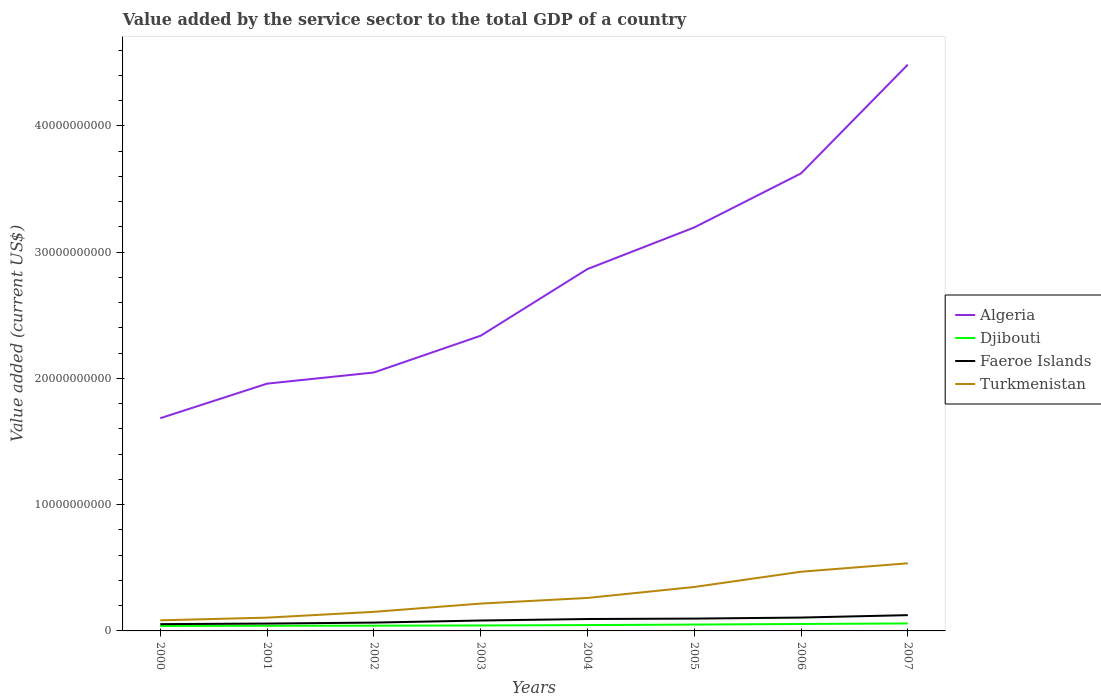Across all years, what is the maximum value added by the service sector to the total GDP in Turkmenistan?
Give a very brief answer. 8.39e+08. In which year was the value added by the service sector to the total GDP in Turkmenistan maximum?
Give a very brief answer. 2000. What is the total value added by the service sector to the total GDP in Djibouti in the graph?
Ensure brevity in your answer.  -9.52e+07. What is the difference between the highest and the second highest value added by the service sector to the total GDP in Djibouti?
Your answer should be very brief. 2.02e+08. What is the difference between the highest and the lowest value added by the service sector to the total GDP in Djibouti?
Provide a short and direct response. 3. How many lines are there?
Offer a terse response. 4. How many years are there in the graph?
Ensure brevity in your answer.  8. What is the difference between two consecutive major ticks on the Y-axis?
Provide a succinct answer. 1.00e+1. Does the graph contain any zero values?
Your answer should be very brief. No. Does the graph contain grids?
Offer a very short reply. No. Where does the legend appear in the graph?
Your response must be concise. Center right. How many legend labels are there?
Offer a terse response. 4. What is the title of the graph?
Ensure brevity in your answer.  Value added by the service sector to the total GDP of a country. Does "Norway" appear as one of the legend labels in the graph?
Provide a succinct answer. No. What is the label or title of the X-axis?
Your response must be concise. Years. What is the label or title of the Y-axis?
Your answer should be compact. Value added (current US$). What is the Value added (current US$) of Algeria in 2000?
Offer a terse response. 1.68e+1. What is the Value added (current US$) in Djibouti in 2000?
Ensure brevity in your answer.  3.90e+08. What is the Value added (current US$) of Faeroe Islands in 2000?
Offer a terse response. 5.37e+08. What is the Value added (current US$) of Turkmenistan in 2000?
Your response must be concise. 8.39e+08. What is the Value added (current US$) in Algeria in 2001?
Your answer should be compact. 1.96e+1. What is the Value added (current US$) in Djibouti in 2001?
Provide a succinct answer. 4.08e+08. What is the Value added (current US$) of Faeroe Islands in 2001?
Offer a terse response. 5.84e+08. What is the Value added (current US$) in Turkmenistan in 2001?
Your answer should be compact. 1.05e+09. What is the Value added (current US$) of Algeria in 2002?
Provide a succinct answer. 2.05e+1. What is the Value added (current US$) in Djibouti in 2002?
Offer a very short reply. 4.16e+08. What is the Value added (current US$) of Faeroe Islands in 2002?
Give a very brief answer. 6.59e+08. What is the Value added (current US$) of Turkmenistan in 2002?
Make the answer very short. 1.51e+09. What is the Value added (current US$) in Algeria in 2003?
Make the answer very short. 2.34e+1. What is the Value added (current US$) in Djibouti in 2003?
Provide a short and direct response. 4.32e+08. What is the Value added (current US$) of Faeroe Islands in 2003?
Offer a very short reply. 8.24e+08. What is the Value added (current US$) of Turkmenistan in 2003?
Make the answer very short. 2.16e+09. What is the Value added (current US$) of Algeria in 2004?
Provide a succinct answer. 2.87e+1. What is the Value added (current US$) of Djibouti in 2004?
Offer a terse response. 4.62e+08. What is the Value added (current US$) of Faeroe Islands in 2004?
Provide a succinct answer. 9.43e+08. What is the Value added (current US$) of Turkmenistan in 2004?
Give a very brief answer. 2.61e+09. What is the Value added (current US$) of Algeria in 2005?
Your answer should be very brief. 3.20e+1. What is the Value added (current US$) of Djibouti in 2005?
Provide a short and direct response. 5.04e+08. What is the Value added (current US$) of Faeroe Islands in 2005?
Keep it short and to the point. 9.77e+08. What is the Value added (current US$) in Turkmenistan in 2005?
Give a very brief answer. 3.48e+09. What is the Value added (current US$) of Algeria in 2006?
Ensure brevity in your answer.  3.62e+1. What is the Value added (current US$) of Djibouti in 2006?
Make the answer very short. 5.49e+08. What is the Value added (current US$) in Faeroe Islands in 2006?
Make the answer very short. 1.06e+09. What is the Value added (current US$) of Turkmenistan in 2006?
Your answer should be very brief. 4.69e+09. What is the Value added (current US$) of Algeria in 2007?
Provide a succinct answer. 4.48e+1. What is the Value added (current US$) of Djibouti in 2007?
Provide a short and direct response. 5.92e+08. What is the Value added (current US$) in Faeroe Islands in 2007?
Offer a very short reply. 1.25e+09. What is the Value added (current US$) of Turkmenistan in 2007?
Make the answer very short. 5.36e+09. Across all years, what is the maximum Value added (current US$) in Algeria?
Your answer should be compact. 4.48e+1. Across all years, what is the maximum Value added (current US$) in Djibouti?
Provide a short and direct response. 5.92e+08. Across all years, what is the maximum Value added (current US$) of Faeroe Islands?
Your response must be concise. 1.25e+09. Across all years, what is the maximum Value added (current US$) of Turkmenistan?
Make the answer very short. 5.36e+09. Across all years, what is the minimum Value added (current US$) in Algeria?
Offer a terse response. 1.68e+1. Across all years, what is the minimum Value added (current US$) of Djibouti?
Your answer should be very brief. 3.90e+08. Across all years, what is the minimum Value added (current US$) of Faeroe Islands?
Provide a short and direct response. 5.37e+08. Across all years, what is the minimum Value added (current US$) in Turkmenistan?
Your response must be concise. 8.39e+08. What is the total Value added (current US$) of Algeria in the graph?
Give a very brief answer. 2.22e+11. What is the total Value added (current US$) of Djibouti in the graph?
Your answer should be very brief. 3.75e+09. What is the total Value added (current US$) in Faeroe Islands in the graph?
Make the answer very short. 6.83e+09. What is the total Value added (current US$) in Turkmenistan in the graph?
Offer a terse response. 2.17e+1. What is the difference between the Value added (current US$) in Algeria in 2000 and that in 2001?
Make the answer very short. -2.74e+09. What is the difference between the Value added (current US$) in Djibouti in 2000 and that in 2001?
Ensure brevity in your answer.  -1.80e+07. What is the difference between the Value added (current US$) of Faeroe Islands in 2000 and that in 2001?
Your answer should be compact. -4.70e+07. What is the difference between the Value added (current US$) in Turkmenistan in 2000 and that in 2001?
Give a very brief answer. -2.13e+08. What is the difference between the Value added (current US$) in Algeria in 2000 and that in 2002?
Your response must be concise. -3.62e+09. What is the difference between the Value added (current US$) in Djibouti in 2000 and that in 2002?
Make the answer very short. -2.58e+07. What is the difference between the Value added (current US$) of Faeroe Islands in 2000 and that in 2002?
Your response must be concise. -1.22e+08. What is the difference between the Value added (current US$) in Turkmenistan in 2000 and that in 2002?
Ensure brevity in your answer.  -6.72e+08. What is the difference between the Value added (current US$) in Algeria in 2000 and that in 2003?
Offer a terse response. -6.53e+09. What is the difference between the Value added (current US$) in Djibouti in 2000 and that in 2003?
Give a very brief answer. -4.19e+07. What is the difference between the Value added (current US$) in Faeroe Islands in 2000 and that in 2003?
Your answer should be very brief. -2.86e+08. What is the difference between the Value added (current US$) of Turkmenistan in 2000 and that in 2003?
Offer a very short reply. -1.33e+09. What is the difference between the Value added (current US$) of Algeria in 2000 and that in 2004?
Give a very brief answer. -1.18e+1. What is the difference between the Value added (current US$) of Djibouti in 2000 and that in 2004?
Make the answer very short. -7.20e+07. What is the difference between the Value added (current US$) of Faeroe Islands in 2000 and that in 2004?
Your answer should be compact. -4.06e+08. What is the difference between the Value added (current US$) in Turkmenistan in 2000 and that in 2004?
Offer a very short reply. -1.77e+09. What is the difference between the Value added (current US$) in Algeria in 2000 and that in 2005?
Provide a succinct answer. -1.51e+1. What is the difference between the Value added (current US$) of Djibouti in 2000 and that in 2005?
Provide a short and direct response. -1.13e+08. What is the difference between the Value added (current US$) of Faeroe Islands in 2000 and that in 2005?
Keep it short and to the point. -4.39e+08. What is the difference between the Value added (current US$) in Turkmenistan in 2000 and that in 2005?
Your answer should be very brief. -2.64e+09. What is the difference between the Value added (current US$) of Algeria in 2000 and that in 2006?
Your response must be concise. -1.94e+1. What is the difference between the Value added (current US$) in Djibouti in 2000 and that in 2006?
Provide a succinct answer. -1.59e+08. What is the difference between the Value added (current US$) in Faeroe Islands in 2000 and that in 2006?
Offer a terse response. -5.21e+08. What is the difference between the Value added (current US$) in Turkmenistan in 2000 and that in 2006?
Provide a short and direct response. -3.85e+09. What is the difference between the Value added (current US$) in Algeria in 2000 and that in 2007?
Provide a short and direct response. -2.80e+1. What is the difference between the Value added (current US$) in Djibouti in 2000 and that in 2007?
Give a very brief answer. -2.02e+08. What is the difference between the Value added (current US$) in Faeroe Islands in 2000 and that in 2007?
Your answer should be very brief. -7.12e+08. What is the difference between the Value added (current US$) of Turkmenistan in 2000 and that in 2007?
Your answer should be compact. -4.52e+09. What is the difference between the Value added (current US$) of Algeria in 2001 and that in 2002?
Your answer should be compact. -8.82e+08. What is the difference between the Value added (current US$) in Djibouti in 2001 and that in 2002?
Your answer should be compact. -7.81e+06. What is the difference between the Value added (current US$) in Faeroe Islands in 2001 and that in 2002?
Provide a succinct answer. -7.46e+07. What is the difference between the Value added (current US$) of Turkmenistan in 2001 and that in 2002?
Offer a terse response. -4.59e+08. What is the difference between the Value added (current US$) of Algeria in 2001 and that in 2003?
Offer a terse response. -3.79e+09. What is the difference between the Value added (current US$) in Djibouti in 2001 and that in 2003?
Offer a very short reply. -2.39e+07. What is the difference between the Value added (current US$) in Faeroe Islands in 2001 and that in 2003?
Provide a succinct answer. -2.39e+08. What is the difference between the Value added (current US$) of Turkmenistan in 2001 and that in 2003?
Your answer should be very brief. -1.11e+09. What is the difference between the Value added (current US$) of Algeria in 2001 and that in 2004?
Your response must be concise. -9.07e+09. What is the difference between the Value added (current US$) of Djibouti in 2001 and that in 2004?
Provide a succinct answer. -5.40e+07. What is the difference between the Value added (current US$) of Faeroe Islands in 2001 and that in 2004?
Give a very brief answer. -3.59e+08. What is the difference between the Value added (current US$) in Turkmenistan in 2001 and that in 2004?
Ensure brevity in your answer.  -1.56e+09. What is the difference between the Value added (current US$) in Algeria in 2001 and that in 2005?
Provide a succinct answer. -1.24e+1. What is the difference between the Value added (current US$) of Djibouti in 2001 and that in 2005?
Keep it short and to the point. -9.52e+07. What is the difference between the Value added (current US$) in Faeroe Islands in 2001 and that in 2005?
Provide a short and direct response. -3.92e+08. What is the difference between the Value added (current US$) in Turkmenistan in 2001 and that in 2005?
Your response must be concise. -2.43e+09. What is the difference between the Value added (current US$) of Algeria in 2001 and that in 2006?
Give a very brief answer. -1.66e+1. What is the difference between the Value added (current US$) in Djibouti in 2001 and that in 2006?
Ensure brevity in your answer.  -1.41e+08. What is the difference between the Value added (current US$) in Faeroe Islands in 2001 and that in 2006?
Provide a short and direct response. -4.74e+08. What is the difference between the Value added (current US$) in Turkmenistan in 2001 and that in 2006?
Your answer should be very brief. -3.64e+09. What is the difference between the Value added (current US$) of Algeria in 2001 and that in 2007?
Provide a short and direct response. -2.53e+1. What is the difference between the Value added (current US$) in Djibouti in 2001 and that in 2007?
Provide a short and direct response. -1.84e+08. What is the difference between the Value added (current US$) of Faeroe Islands in 2001 and that in 2007?
Give a very brief answer. -6.65e+08. What is the difference between the Value added (current US$) in Turkmenistan in 2001 and that in 2007?
Your response must be concise. -4.30e+09. What is the difference between the Value added (current US$) in Algeria in 2002 and that in 2003?
Your response must be concise. -2.91e+09. What is the difference between the Value added (current US$) in Djibouti in 2002 and that in 2003?
Give a very brief answer. -1.61e+07. What is the difference between the Value added (current US$) in Faeroe Islands in 2002 and that in 2003?
Give a very brief answer. -1.65e+08. What is the difference between the Value added (current US$) in Turkmenistan in 2002 and that in 2003?
Provide a succinct answer. -6.54e+08. What is the difference between the Value added (current US$) of Algeria in 2002 and that in 2004?
Offer a very short reply. -8.19e+09. What is the difference between the Value added (current US$) in Djibouti in 2002 and that in 2004?
Offer a terse response. -4.62e+07. What is the difference between the Value added (current US$) of Faeroe Islands in 2002 and that in 2004?
Provide a succinct answer. -2.84e+08. What is the difference between the Value added (current US$) in Turkmenistan in 2002 and that in 2004?
Provide a short and direct response. -1.10e+09. What is the difference between the Value added (current US$) in Algeria in 2002 and that in 2005?
Your answer should be compact. -1.15e+1. What is the difference between the Value added (current US$) of Djibouti in 2002 and that in 2005?
Your response must be concise. -8.74e+07. What is the difference between the Value added (current US$) of Faeroe Islands in 2002 and that in 2005?
Your response must be concise. -3.18e+08. What is the difference between the Value added (current US$) in Turkmenistan in 2002 and that in 2005?
Provide a short and direct response. -1.97e+09. What is the difference between the Value added (current US$) in Algeria in 2002 and that in 2006?
Your response must be concise. -1.58e+1. What is the difference between the Value added (current US$) of Djibouti in 2002 and that in 2006?
Offer a terse response. -1.33e+08. What is the difference between the Value added (current US$) of Faeroe Islands in 2002 and that in 2006?
Make the answer very short. -3.99e+08. What is the difference between the Value added (current US$) of Turkmenistan in 2002 and that in 2006?
Your answer should be compact. -3.18e+09. What is the difference between the Value added (current US$) of Algeria in 2002 and that in 2007?
Ensure brevity in your answer.  -2.44e+1. What is the difference between the Value added (current US$) of Djibouti in 2002 and that in 2007?
Give a very brief answer. -1.76e+08. What is the difference between the Value added (current US$) in Faeroe Islands in 2002 and that in 2007?
Make the answer very short. -5.91e+08. What is the difference between the Value added (current US$) in Turkmenistan in 2002 and that in 2007?
Make the answer very short. -3.84e+09. What is the difference between the Value added (current US$) of Algeria in 2003 and that in 2004?
Make the answer very short. -5.28e+09. What is the difference between the Value added (current US$) in Djibouti in 2003 and that in 2004?
Offer a terse response. -3.01e+07. What is the difference between the Value added (current US$) of Faeroe Islands in 2003 and that in 2004?
Provide a short and direct response. -1.20e+08. What is the difference between the Value added (current US$) of Turkmenistan in 2003 and that in 2004?
Provide a short and direct response. -4.47e+08. What is the difference between the Value added (current US$) of Algeria in 2003 and that in 2005?
Give a very brief answer. -8.58e+09. What is the difference between the Value added (current US$) of Djibouti in 2003 and that in 2005?
Your answer should be compact. -7.13e+07. What is the difference between the Value added (current US$) of Faeroe Islands in 2003 and that in 2005?
Your answer should be compact. -1.53e+08. What is the difference between the Value added (current US$) of Turkmenistan in 2003 and that in 2005?
Your response must be concise. -1.32e+09. What is the difference between the Value added (current US$) in Algeria in 2003 and that in 2006?
Give a very brief answer. -1.29e+1. What is the difference between the Value added (current US$) in Djibouti in 2003 and that in 2006?
Your response must be concise. -1.17e+08. What is the difference between the Value added (current US$) of Faeroe Islands in 2003 and that in 2006?
Provide a short and direct response. -2.35e+08. What is the difference between the Value added (current US$) of Turkmenistan in 2003 and that in 2006?
Ensure brevity in your answer.  -2.52e+09. What is the difference between the Value added (current US$) of Algeria in 2003 and that in 2007?
Provide a succinct answer. -2.15e+1. What is the difference between the Value added (current US$) in Djibouti in 2003 and that in 2007?
Provide a short and direct response. -1.60e+08. What is the difference between the Value added (current US$) of Faeroe Islands in 2003 and that in 2007?
Offer a terse response. -4.26e+08. What is the difference between the Value added (current US$) of Turkmenistan in 2003 and that in 2007?
Provide a succinct answer. -3.19e+09. What is the difference between the Value added (current US$) in Algeria in 2004 and that in 2005?
Provide a short and direct response. -3.29e+09. What is the difference between the Value added (current US$) of Djibouti in 2004 and that in 2005?
Your response must be concise. -4.12e+07. What is the difference between the Value added (current US$) of Faeroe Islands in 2004 and that in 2005?
Provide a succinct answer. -3.36e+07. What is the difference between the Value added (current US$) of Turkmenistan in 2004 and that in 2005?
Your answer should be compact. -8.68e+08. What is the difference between the Value added (current US$) of Algeria in 2004 and that in 2006?
Ensure brevity in your answer.  -7.58e+09. What is the difference between the Value added (current US$) of Djibouti in 2004 and that in 2006?
Your response must be concise. -8.69e+07. What is the difference between the Value added (current US$) of Faeroe Islands in 2004 and that in 2006?
Give a very brief answer. -1.15e+08. What is the difference between the Value added (current US$) in Turkmenistan in 2004 and that in 2006?
Provide a succinct answer. -2.08e+09. What is the difference between the Value added (current US$) of Algeria in 2004 and that in 2007?
Make the answer very short. -1.62e+1. What is the difference between the Value added (current US$) of Djibouti in 2004 and that in 2007?
Your answer should be very brief. -1.30e+08. What is the difference between the Value added (current US$) of Faeroe Islands in 2004 and that in 2007?
Keep it short and to the point. -3.07e+08. What is the difference between the Value added (current US$) in Turkmenistan in 2004 and that in 2007?
Your answer should be very brief. -2.74e+09. What is the difference between the Value added (current US$) in Algeria in 2005 and that in 2006?
Provide a succinct answer. -4.28e+09. What is the difference between the Value added (current US$) in Djibouti in 2005 and that in 2006?
Offer a terse response. -4.57e+07. What is the difference between the Value added (current US$) in Faeroe Islands in 2005 and that in 2006?
Your answer should be compact. -8.14e+07. What is the difference between the Value added (current US$) of Turkmenistan in 2005 and that in 2006?
Provide a short and direct response. -1.21e+09. What is the difference between the Value added (current US$) of Algeria in 2005 and that in 2007?
Give a very brief answer. -1.29e+1. What is the difference between the Value added (current US$) of Djibouti in 2005 and that in 2007?
Your answer should be compact. -8.87e+07. What is the difference between the Value added (current US$) in Faeroe Islands in 2005 and that in 2007?
Keep it short and to the point. -2.73e+08. What is the difference between the Value added (current US$) in Turkmenistan in 2005 and that in 2007?
Ensure brevity in your answer.  -1.88e+09. What is the difference between the Value added (current US$) in Algeria in 2006 and that in 2007?
Provide a succinct answer. -8.61e+09. What is the difference between the Value added (current US$) of Djibouti in 2006 and that in 2007?
Your response must be concise. -4.30e+07. What is the difference between the Value added (current US$) in Faeroe Islands in 2006 and that in 2007?
Keep it short and to the point. -1.92e+08. What is the difference between the Value added (current US$) in Turkmenistan in 2006 and that in 2007?
Provide a short and direct response. -6.68e+08. What is the difference between the Value added (current US$) of Algeria in 2000 and the Value added (current US$) of Djibouti in 2001?
Make the answer very short. 1.64e+1. What is the difference between the Value added (current US$) in Algeria in 2000 and the Value added (current US$) in Faeroe Islands in 2001?
Provide a succinct answer. 1.63e+1. What is the difference between the Value added (current US$) in Algeria in 2000 and the Value added (current US$) in Turkmenistan in 2001?
Give a very brief answer. 1.58e+1. What is the difference between the Value added (current US$) in Djibouti in 2000 and the Value added (current US$) in Faeroe Islands in 2001?
Offer a terse response. -1.94e+08. What is the difference between the Value added (current US$) of Djibouti in 2000 and the Value added (current US$) of Turkmenistan in 2001?
Make the answer very short. -6.62e+08. What is the difference between the Value added (current US$) of Faeroe Islands in 2000 and the Value added (current US$) of Turkmenistan in 2001?
Give a very brief answer. -5.15e+08. What is the difference between the Value added (current US$) in Algeria in 2000 and the Value added (current US$) in Djibouti in 2002?
Your response must be concise. 1.64e+1. What is the difference between the Value added (current US$) of Algeria in 2000 and the Value added (current US$) of Faeroe Islands in 2002?
Offer a terse response. 1.62e+1. What is the difference between the Value added (current US$) in Algeria in 2000 and the Value added (current US$) in Turkmenistan in 2002?
Your answer should be compact. 1.53e+1. What is the difference between the Value added (current US$) of Djibouti in 2000 and the Value added (current US$) of Faeroe Islands in 2002?
Keep it short and to the point. -2.69e+08. What is the difference between the Value added (current US$) of Djibouti in 2000 and the Value added (current US$) of Turkmenistan in 2002?
Offer a very short reply. -1.12e+09. What is the difference between the Value added (current US$) of Faeroe Islands in 2000 and the Value added (current US$) of Turkmenistan in 2002?
Give a very brief answer. -9.74e+08. What is the difference between the Value added (current US$) of Algeria in 2000 and the Value added (current US$) of Djibouti in 2003?
Offer a terse response. 1.64e+1. What is the difference between the Value added (current US$) in Algeria in 2000 and the Value added (current US$) in Faeroe Islands in 2003?
Offer a terse response. 1.60e+1. What is the difference between the Value added (current US$) in Algeria in 2000 and the Value added (current US$) in Turkmenistan in 2003?
Ensure brevity in your answer.  1.47e+1. What is the difference between the Value added (current US$) of Djibouti in 2000 and the Value added (current US$) of Faeroe Islands in 2003?
Your answer should be very brief. -4.33e+08. What is the difference between the Value added (current US$) of Djibouti in 2000 and the Value added (current US$) of Turkmenistan in 2003?
Give a very brief answer. -1.77e+09. What is the difference between the Value added (current US$) in Faeroe Islands in 2000 and the Value added (current US$) in Turkmenistan in 2003?
Offer a very short reply. -1.63e+09. What is the difference between the Value added (current US$) in Algeria in 2000 and the Value added (current US$) in Djibouti in 2004?
Provide a succinct answer. 1.64e+1. What is the difference between the Value added (current US$) of Algeria in 2000 and the Value added (current US$) of Faeroe Islands in 2004?
Your answer should be compact. 1.59e+1. What is the difference between the Value added (current US$) in Algeria in 2000 and the Value added (current US$) in Turkmenistan in 2004?
Offer a terse response. 1.42e+1. What is the difference between the Value added (current US$) in Djibouti in 2000 and the Value added (current US$) in Faeroe Islands in 2004?
Your answer should be compact. -5.53e+08. What is the difference between the Value added (current US$) in Djibouti in 2000 and the Value added (current US$) in Turkmenistan in 2004?
Your answer should be compact. -2.22e+09. What is the difference between the Value added (current US$) in Faeroe Islands in 2000 and the Value added (current US$) in Turkmenistan in 2004?
Ensure brevity in your answer.  -2.07e+09. What is the difference between the Value added (current US$) of Algeria in 2000 and the Value added (current US$) of Djibouti in 2005?
Keep it short and to the point. 1.63e+1. What is the difference between the Value added (current US$) of Algeria in 2000 and the Value added (current US$) of Faeroe Islands in 2005?
Make the answer very short. 1.59e+1. What is the difference between the Value added (current US$) of Algeria in 2000 and the Value added (current US$) of Turkmenistan in 2005?
Keep it short and to the point. 1.34e+1. What is the difference between the Value added (current US$) of Djibouti in 2000 and the Value added (current US$) of Faeroe Islands in 2005?
Make the answer very short. -5.86e+08. What is the difference between the Value added (current US$) of Djibouti in 2000 and the Value added (current US$) of Turkmenistan in 2005?
Give a very brief answer. -3.09e+09. What is the difference between the Value added (current US$) in Faeroe Islands in 2000 and the Value added (current US$) in Turkmenistan in 2005?
Provide a short and direct response. -2.94e+09. What is the difference between the Value added (current US$) in Algeria in 2000 and the Value added (current US$) in Djibouti in 2006?
Keep it short and to the point. 1.63e+1. What is the difference between the Value added (current US$) of Algeria in 2000 and the Value added (current US$) of Faeroe Islands in 2006?
Make the answer very short. 1.58e+1. What is the difference between the Value added (current US$) in Algeria in 2000 and the Value added (current US$) in Turkmenistan in 2006?
Provide a short and direct response. 1.22e+1. What is the difference between the Value added (current US$) of Djibouti in 2000 and the Value added (current US$) of Faeroe Islands in 2006?
Make the answer very short. -6.68e+08. What is the difference between the Value added (current US$) of Djibouti in 2000 and the Value added (current US$) of Turkmenistan in 2006?
Provide a succinct answer. -4.30e+09. What is the difference between the Value added (current US$) in Faeroe Islands in 2000 and the Value added (current US$) in Turkmenistan in 2006?
Keep it short and to the point. -4.15e+09. What is the difference between the Value added (current US$) of Algeria in 2000 and the Value added (current US$) of Djibouti in 2007?
Give a very brief answer. 1.63e+1. What is the difference between the Value added (current US$) of Algeria in 2000 and the Value added (current US$) of Faeroe Islands in 2007?
Provide a short and direct response. 1.56e+1. What is the difference between the Value added (current US$) of Algeria in 2000 and the Value added (current US$) of Turkmenistan in 2007?
Your answer should be very brief. 1.15e+1. What is the difference between the Value added (current US$) of Djibouti in 2000 and the Value added (current US$) of Faeroe Islands in 2007?
Provide a succinct answer. -8.59e+08. What is the difference between the Value added (current US$) in Djibouti in 2000 and the Value added (current US$) in Turkmenistan in 2007?
Your response must be concise. -4.97e+09. What is the difference between the Value added (current US$) in Faeroe Islands in 2000 and the Value added (current US$) in Turkmenistan in 2007?
Your response must be concise. -4.82e+09. What is the difference between the Value added (current US$) of Algeria in 2001 and the Value added (current US$) of Djibouti in 2002?
Make the answer very short. 1.92e+1. What is the difference between the Value added (current US$) in Algeria in 2001 and the Value added (current US$) in Faeroe Islands in 2002?
Your answer should be compact. 1.89e+1. What is the difference between the Value added (current US$) in Algeria in 2001 and the Value added (current US$) in Turkmenistan in 2002?
Your answer should be very brief. 1.81e+1. What is the difference between the Value added (current US$) of Djibouti in 2001 and the Value added (current US$) of Faeroe Islands in 2002?
Give a very brief answer. -2.51e+08. What is the difference between the Value added (current US$) in Djibouti in 2001 and the Value added (current US$) in Turkmenistan in 2002?
Your answer should be compact. -1.10e+09. What is the difference between the Value added (current US$) of Faeroe Islands in 2001 and the Value added (current US$) of Turkmenistan in 2002?
Offer a very short reply. -9.27e+08. What is the difference between the Value added (current US$) in Algeria in 2001 and the Value added (current US$) in Djibouti in 2003?
Make the answer very short. 1.91e+1. What is the difference between the Value added (current US$) in Algeria in 2001 and the Value added (current US$) in Faeroe Islands in 2003?
Offer a very short reply. 1.88e+1. What is the difference between the Value added (current US$) of Algeria in 2001 and the Value added (current US$) of Turkmenistan in 2003?
Your response must be concise. 1.74e+1. What is the difference between the Value added (current US$) in Djibouti in 2001 and the Value added (current US$) in Faeroe Islands in 2003?
Ensure brevity in your answer.  -4.15e+08. What is the difference between the Value added (current US$) in Djibouti in 2001 and the Value added (current US$) in Turkmenistan in 2003?
Provide a succinct answer. -1.76e+09. What is the difference between the Value added (current US$) in Faeroe Islands in 2001 and the Value added (current US$) in Turkmenistan in 2003?
Provide a short and direct response. -1.58e+09. What is the difference between the Value added (current US$) of Algeria in 2001 and the Value added (current US$) of Djibouti in 2004?
Offer a terse response. 1.91e+1. What is the difference between the Value added (current US$) in Algeria in 2001 and the Value added (current US$) in Faeroe Islands in 2004?
Ensure brevity in your answer.  1.86e+1. What is the difference between the Value added (current US$) in Algeria in 2001 and the Value added (current US$) in Turkmenistan in 2004?
Your response must be concise. 1.70e+1. What is the difference between the Value added (current US$) of Djibouti in 2001 and the Value added (current US$) of Faeroe Islands in 2004?
Provide a succinct answer. -5.35e+08. What is the difference between the Value added (current US$) of Djibouti in 2001 and the Value added (current US$) of Turkmenistan in 2004?
Give a very brief answer. -2.20e+09. What is the difference between the Value added (current US$) of Faeroe Islands in 2001 and the Value added (current US$) of Turkmenistan in 2004?
Provide a short and direct response. -2.03e+09. What is the difference between the Value added (current US$) of Algeria in 2001 and the Value added (current US$) of Djibouti in 2005?
Make the answer very short. 1.91e+1. What is the difference between the Value added (current US$) in Algeria in 2001 and the Value added (current US$) in Faeroe Islands in 2005?
Make the answer very short. 1.86e+1. What is the difference between the Value added (current US$) of Algeria in 2001 and the Value added (current US$) of Turkmenistan in 2005?
Provide a short and direct response. 1.61e+1. What is the difference between the Value added (current US$) in Djibouti in 2001 and the Value added (current US$) in Faeroe Islands in 2005?
Give a very brief answer. -5.68e+08. What is the difference between the Value added (current US$) of Djibouti in 2001 and the Value added (current US$) of Turkmenistan in 2005?
Provide a short and direct response. -3.07e+09. What is the difference between the Value added (current US$) of Faeroe Islands in 2001 and the Value added (current US$) of Turkmenistan in 2005?
Your response must be concise. -2.90e+09. What is the difference between the Value added (current US$) of Algeria in 2001 and the Value added (current US$) of Djibouti in 2006?
Offer a very short reply. 1.90e+1. What is the difference between the Value added (current US$) in Algeria in 2001 and the Value added (current US$) in Faeroe Islands in 2006?
Offer a very short reply. 1.85e+1. What is the difference between the Value added (current US$) of Algeria in 2001 and the Value added (current US$) of Turkmenistan in 2006?
Your response must be concise. 1.49e+1. What is the difference between the Value added (current US$) of Djibouti in 2001 and the Value added (current US$) of Faeroe Islands in 2006?
Keep it short and to the point. -6.50e+08. What is the difference between the Value added (current US$) of Djibouti in 2001 and the Value added (current US$) of Turkmenistan in 2006?
Provide a short and direct response. -4.28e+09. What is the difference between the Value added (current US$) in Faeroe Islands in 2001 and the Value added (current US$) in Turkmenistan in 2006?
Ensure brevity in your answer.  -4.10e+09. What is the difference between the Value added (current US$) of Algeria in 2001 and the Value added (current US$) of Djibouti in 2007?
Offer a terse response. 1.90e+1. What is the difference between the Value added (current US$) of Algeria in 2001 and the Value added (current US$) of Faeroe Islands in 2007?
Your answer should be very brief. 1.83e+1. What is the difference between the Value added (current US$) of Algeria in 2001 and the Value added (current US$) of Turkmenistan in 2007?
Ensure brevity in your answer.  1.42e+1. What is the difference between the Value added (current US$) of Djibouti in 2001 and the Value added (current US$) of Faeroe Islands in 2007?
Make the answer very short. -8.41e+08. What is the difference between the Value added (current US$) in Djibouti in 2001 and the Value added (current US$) in Turkmenistan in 2007?
Make the answer very short. -4.95e+09. What is the difference between the Value added (current US$) in Faeroe Islands in 2001 and the Value added (current US$) in Turkmenistan in 2007?
Provide a short and direct response. -4.77e+09. What is the difference between the Value added (current US$) in Algeria in 2002 and the Value added (current US$) in Djibouti in 2003?
Ensure brevity in your answer.  2.00e+1. What is the difference between the Value added (current US$) of Algeria in 2002 and the Value added (current US$) of Faeroe Islands in 2003?
Your answer should be compact. 1.96e+1. What is the difference between the Value added (current US$) of Algeria in 2002 and the Value added (current US$) of Turkmenistan in 2003?
Provide a succinct answer. 1.83e+1. What is the difference between the Value added (current US$) of Djibouti in 2002 and the Value added (current US$) of Faeroe Islands in 2003?
Give a very brief answer. -4.07e+08. What is the difference between the Value added (current US$) in Djibouti in 2002 and the Value added (current US$) in Turkmenistan in 2003?
Ensure brevity in your answer.  -1.75e+09. What is the difference between the Value added (current US$) of Faeroe Islands in 2002 and the Value added (current US$) of Turkmenistan in 2003?
Ensure brevity in your answer.  -1.51e+09. What is the difference between the Value added (current US$) in Algeria in 2002 and the Value added (current US$) in Djibouti in 2004?
Offer a terse response. 2.00e+1. What is the difference between the Value added (current US$) in Algeria in 2002 and the Value added (current US$) in Faeroe Islands in 2004?
Give a very brief answer. 1.95e+1. What is the difference between the Value added (current US$) in Algeria in 2002 and the Value added (current US$) in Turkmenistan in 2004?
Make the answer very short. 1.79e+1. What is the difference between the Value added (current US$) in Djibouti in 2002 and the Value added (current US$) in Faeroe Islands in 2004?
Provide a short and direct response. -5.27e+08. What is the difference between the Value added (current US$) of Djibouti in 2002 and the Value added (current US$) of Turkmenistan in 2004?
Provide a succinct answer. -2.20e+09. What is the difference between the Value added (current US$) of Faeroe Islands in 2002 and the Value added (current US$) of Turkmenistan in 2004?
Your response must be concise. -1.95e+09. What is the difference between the Value added (current US$) in Algeria in 2002 and the Value added (current US$) in Djibouti in 2005?
Ensure brevity in your answer.  2.00e+1. What is the difference between the Value added (current US$) in Algeria in 2002 and the Value added (current US$) in Faeroe Islands in 2005?
Your answer should be very brief. 1.95e+1. What is the difference between the Value added (current US$) in Algeria in 2002 and the Value added (current US$) in Turkmenistan in 2005?
Your answer should be compact. 1.70e+1. What is the difference between the Value added (current US$) in Djibouti in 2002 and the Value added (current US$) in Faeroe Islands in 2005?
Make the answer very short. -5.60e+08. What is the difference between the Value added (current US$) in Djibouti in 2002 and the Value added (current US$) in Turkmenistan in 2005?
Your response must be concise. -3.06e+09. What is the difference between the Value added (current US$) in Faeroe Islands in 2002 and the Value added (current US$) in Turkmenistan in 2005?
Your answer should be very brief. -2.82e+09. What is the difference between the Value added (current US$) in Algeria in 2002 and the Value added (current US$) in Djibouti in 2006?
Keep it short and to the point. 1.99e+1. What is the difference between the Value added (current US$) of Algeria in 2002 and the Value added (current US$) of Faeroe Islands in 2006?
Make the answer very short. 1.94e+1. What is the difference between the Value added (current US$) of Algeria in 2002 and the Value added (current US$) of Turkmenistan in 2006?
Keep it short and to the point. 1.58e+1. What is the difference between the Value added (current US$) in Djibouti in 2002 and the Value added (current US$) in Faeroe Islands in 2006?
Make the answer very short. -6.42e+08. What is the difference between the Value added (current US$) in Djibouti in 2002 and the Value added (current US$) in Turkmenistan in 2006?
Ensure brevity in your answer.  -4.27e+09. What is the difference between the Value added (current US$) in Faeroe Islands in 2002 and the Value added (current US$) in Turkmenistan in 2006?
Your response must be concise. -4.03e+09. What is the difference between the Value added (current US$) of Algeria in 2002 and the Value added (current US$) of Djibouti in 2007?
Ensure brevity in your answer.  1.99e+1. What is the difference between the Value added (current US$) in Algeria in 2002 and the Value added (current US$) in Faeroe Islands in 2007?
Provide a succinct answer. 1.92e+1. What is the difference between the Value added (current US$) in Algeria in 2002 and the Value added (current US$) in Turkmenistan in 2007?
Offer a very short reply. 1.51e+1. What is the difference between the Value added (current US$) of Djibouti in 2002 and the Value added (current US$) of Faeroe Islands in 2007?
Your answer should be compact. -8.34e+08. What is the difference between the Value added (current US$) in Djibouti in 2002 and the Value added (current US$) in Turkmenistan in 2007?
Ensure brevity in your answer.  -4.94e+09. What is the difference between the Value added (current US$) in Faeroe Islands in 2002 and the Value added (current US$) in Turkmenistan in 2007?
Your response must be concise. -4.70e+09. What is the difference between the Value added (current US$) of Algeria in 2003 and the Value added (current US$) of Djibouti in 2004?
Your answer should be very brief. 2.29e+1. What is the difference between the Value added (current US$) in Algeria in 2003 and the Value added (current US$) in Faeroe Islands in 2004?
Offer a terse response. 2.24e+1. What is the difference between the Value added (current US$) in Algeria in 2003 and the Value added (current US$) in Turkmenistan in 2004?
Your answer should be compact. 2.08e+1. What is the difference between the Value added (current US$) in Djibouti in 2003 and the Value added (current US$) in Faeroe Islands in 2004?
Your answer should be compact. -5.11e+08. What is the difference between the Value added (current US$) in Djibouti in 2003 and the Value added (current US$) in Turkmenistan in 2004?
Give a very brief answer. -2.18e+09. What is the difference between the Value added (current US$) in Faeroe Islands in 2003 and the Value added (current US$) in Turkmenistan in 2004?
Your answer should be very brief. -1.79e+09. What is the difference between the Value added (current US$) in Algeria in 2003 and the Value added (current US$) in Djibouti in 2005?
Offer a very short reply. 2.29e+1. What is the difference between the Value added (current US$) of Algeria in 2003 and the Value added (current US$) of Faeroe Islands in 2005?
Provide a succinct answer. 2.24e+1. What is the difference between the Value added (current US$) of Algeria in 2003 and the Value added (current US$) of Turkmenistan in 2005?
Provide a short and direct response. 1.99e+1. What is the difference between the Value added (current US$) of Djibouti in 2003 and the Value added (current US$) of Faeroe Islands in 2005?
Make the answer very short. -5.44e+08. What is the difference between the Value added (current US$) of Djibouti in 2003 and the Value added (current US$) of Turkmenistan in 2005?
Your response must be concise. -3.05e+09. What is the difference between the Value added (current US$) of Faeroe Islands in 2003 and the Value added (current US$) of Turkmenistan in 2005?
Provide a succinct answer. -2.66e+09. What is the difference between the Value added (current US$) of Algeria in 2003 and the Value added (current US$) of Djibouti in 2006?
Your answer should be very brief. 2.28e+1. What is the difference between the Value added (current US$) of Algeria in 2003 and the Value added (current US$) of Faeroe Islands in 2006?
Your response must be concise. 2.23e+1. What is the difference between the Value added (current US$) of Algeria in 2003 and the Value added (current US$) of Turkmenistan in 2006?
Keep it short and to the point. 1.87e+1. What is the difference between the Value added (current US$) in Djibouti in 2003 and the Value added (current US$) in Faeroe Islands in 2006?
Keep it short and to the point. -6.26e+08. What is the difference between the Value added (current US$) in Djibouti in 2003 and the Value added (current US$) in Turkmenistan in 2006?
Make the answer very short. -4.26e+09. What is the difference between the Value added (current US$) in Faeroe Islands in 2003 and the Value added (current US$) in Turkmenistan in 2006?
Provide a short and direct response. -3.86e+09. What is the difference between the Value added (current US$) of Algeria in 2003 and the Value added (current US$) of Djibouti in 2007?
Provide a succinct answer. 2.28e+1. What is the difference between the Value added (current US$) in Algeria in 2003 and the Value added (current US$) in Faeroe Islands in 2007?
Give a very brief answer. 2.21e+1. What is the difference between the Value added (current US$) in Algeria in 2003 and the Value added (current US$) in Turkmenistan in 2007?
Ensure brevity in your answer.  1.80e+1. What is the difference between the Value added (current US$) of Djibouti in 2003 and the Value added (current US$) of Faeroe Islands in 2007?
Offer a very short reply. -8.17e+08. What is the difference between the Value added (current US$) of Djibouti in 2003 and the Value added (current US$) of Turkmenistan in 2007?
Provide a short and direct response. -4.92e+09. What is the difference between the Value added (current US$) of Faeroe Islands in 2003 and the Value added (current US$) of Turkmenistan in 2007?
Offer a very short reply. -4.53e+09. What is the difference between the Value added (current US$) in Algeria in 2004 and the Value added (current US$) in Djibouti in 2005?
Your answer should be very brief. 2.82e+1. What is the difference between the Value added (current US$) of Algeria in 2004 and the Value added (current US$) of Faeroe Islands in 2005?
Offer a very short reply. 2.77e+1. What is the difference between the Value added (current US$) of Algeria in 2004 and the Value added (current US$) of Turkmenistan in 2005?
Your response must be concise. 2.52e+1. What is the difference between the Value added (current US$) in Djibouti in 2004 and the Value added (current US$) in Faeroe Islands in 2005?
Offer a terse response. -5.14e+08. What is the difference between the Value added (current US$) in Djibouti in 2004 and the Value added (current US$) in Turkmenistan in 2005?
Make the answer very short. -3.02e+09. What is the difference between the Value added (current US$) of Faeroe Islands in 2004 and the Value added (current US$) of Turkmenistan in 2005?
Your answer should be compact. -2.54e+09. What is the difference between the Value added (current US$) of Algeria in 2004 and the Value added (current US$) of Djibouti in 2006?
Provide a short and direct response. 2.81e+1. What is the difference between the Value added (current US$) in Algeria in 2004 and the Value added (current US$) in Faeroe Islands in 2006?
Your response must be concise. 2.76e+1. What is the difference between the Value added (current US$) in Algeria in 2004 and the Value added (current US$) in Turkmenistan in 2006?
Give a very brief answer. 2.40e+1. What is the difference between the Value added (current US$) in Djibouti in 2004 and the Value added (current US$) in Faeroe Islands in 2006?
Keep it short and to the point. -5.96e+08. What is the difference between the Value added (current US$) in Djibouti in 2004 and the Value added (current US$) in Turkmenistan in 2006?
Your response must be concise. -4.22e+09. What is the difference between the Value added (current US$) in Faeroe Islands in 2004 and the Value added (current US$) in Turkmenistan in 2006?
Your response must be concise. -3.74e+09. What is the difference between the Value added (current US$) of Algeria in 2004 and the Value added (current US$) of Djibouti in 2007?
Keep it short and to the point. 2.81e+1. What is the difference between the Value added (current US$) in Algeria in 2004 and the Value added (current US$) in Faeroe Islands in 2007?
Keep it short and to the point. 2.74e+1. What is the difference between the Value added (current US$) in Algeria in 2004 and the Value added (current US$) in Turkmenistan in 2007?
Keep it short and to the point. 2.33e+1. What is the difference between the Value added (current US$) in Djibouti in 2004 and the Value added (current US$) in Faeroe Islands in 2007?
Your answer should be very brief. -7.87e+08. What is the difference between the Value added (current US$) in Djibouti in 2004 and the Value added (current US$) in Turkmenistan in 2007?
Provide a succinct answer. -4.89e+09. What is the difference between the Value added (current US$) of Faeroe Islands in 2004 and the Value added (current US$) of Turkmenistan in 2007?
Offer a terse response. -4.41e+09. What is the difference between the Value added (current US$) in Algeria in 2005 and the Value added (current US$) in Djibouti in 2006?
Make the answer very short. 3.14e+1. What is the difference between the Value added (current US$) in Algeria in 2005 and the Value added (current US$) in Faeroe Islands in 2006?
Provide a short and direct response. 3.09e+1. What is the difference between the Value added (current US$) of Algeria in 2005 and the Value added (current US$) of Turkmenistan in 2006?
Ensure brevity in your answer.  2.73e+1. What is the difference between the Value added (current US$) in Djibouti in 2005 and the Value added (current US$) in Faeroe Islands in 2006?
Provide a succinct answer. -5.54e+08. What is the difference between the Value added (current US$) of Djibouti in 2005 and the Value added (current US$) of Turkmenistan in 2006?
Your response must be concise. -4.18e+09. What is the difference between the Value added (current US$) of Faeroe Islands in 2005 and the Value added (current US$) of Turkmenistan in 2006?
Provide a short and direct response. -3.71e+09. What is the difference between the Value added (current US$) of Algeria in 2005 and the Value added (current US$) of Djibouti in 2007?
Make the answer very short. 3.14e+1. What is the difference between the Value added (current US$) in Algeria in 2005 and the Value added (current US$) in Faeroe Islands in 2007?
Make the answer very short. 3.07e+1. What is the difference between the Value added (current US$) of Algeria in 2005 and the Value added (current US$) of Turkmenistan in 2007?
Your answer should be very brief. 2.66e+1. What is the difference between the Value added (current US$) of Djibouti in 2005 and the Value added (current US$) of Faeroe Islands in 2007?
Provide a succinct answer. -7.46e+08. What is the difference between the Value added (current US$) of Djibouti in 2005 and the Value added (current US$) of Turkmenistan in 2007?
Provide a succinct answer. -4.85e+09. What is the difference between the Value added (current US$) in Faeroe Islands in 2005 and the Value added (current US$) in Turkmenistan in 2007?
Your answer should be compact. -4.38e+09. What is the difference between the Value added (current US$) of Algeria in 2006 and the Value added (current US$) of Djibouti in 2007?
Provide a short and direct response. 3.56e+1. What is the difference between the Value added (current US$) of Algeria in 2006 and the Value added (current US$) of Faeroe Islands in 2007?
Keep it short and to the point. 3.50e+1. What is the difference between the Value added (current US$) of Algeria in 2006 and the Value added (current US$) of Turkmenistan in 2007?
Provide a succinct answer. 3.09e+1. What is the difference between the Value added (current US$) of Djibouti in 2006 and the Value added (current US$) of Faeroe Islands in 2007?
Your answer should be compact. -7.00e+08. What is the difference between the Value added (current US$) of Djibouti in 2006 and the Value added (current US$) of Turkmenistan in 2007?
Make the answer very short. -4.81e+09. What is the difference between the Value added (current US$) of Faeroe Islands in 2006 and the Value added (current US$) of Turkmenistan in 2007?
Your answer should be very brief. -4.30e+09. What is the average Value added (current US$) of Algeria per year?
Provide a succinct answer. 2.77e+1. What is the average Value added (current US$) of Djibouti per year?
Give a very brief answer. 4.69e+08. What is the average Value added (current US$) in Faeroe Islands per year?
Your answer should be very brief. 8.54e+08. What is the average Value added (current US$) of Turkmenistan per year?
Offer a very short reply. 2.71e+09. In the year 2000, what is the difference between the Value added (current US$) in Algeria and Value added (current US$) in Djibouti?
Offer a very short reply. 1.65e+1. In the year 2000, what is the difference between the Value added (current US$) in Algeria and Value added (current US$) in Faeroe Islands?
Provide a succinct answer. 1.63e+1. In the year 2000, what is the difference between the Value added (current US$) of Algeria and Value added (current US$) of Turkmenistan?
Ensure brevity in your answer.  1.60e+1. In the year 2000, what is the difference between the Value added (current US$) of Djibouti and Value added (current US$) of Faeroe Islands?
Ensure brevity in your answer.  -1.47e+08. In the year 2000, what is the difference between the Value added (current US$) of Djibouti and Value added (current US$) of Turkmenistan?
Provide a short and direct response. -4.49e+08. In the year 2000, what is the difference between the Value added (current US$) in Faeroe Islands and Value added (current US$) in Turkmenistan?
Your response must be concise. -3.02e+08. In the year 2001, what is the difference between the Value added (current US$) of Algeria and Value added (current US$) of Djibouti?
Give a very brief answer. 1.92e+1. In the year 2001, what is the difference between the Value added (current US$) of Algeria and Value added (current US$) of Faeroe Islands?
Provide a succinct answer. 1.90e+1. In the year 2001, what is the difference between the Value added (current US$) in Algeria and Value added (current US$) in Turkmenistan?
Provide a succinct answer. 1.85e+1. In the year 2001, what is the difference between the Value added (current US$) in Djibouti and Value added (current US$) in Faeroe Islands?
Offer a very short reply. -1.76e+08. In the year 2001, what is the difference between the Value added (current US$) of Djibouti and Value added (current US$) of Turkmenistan?
Provide a short and direct response. -6.44e+08. In the year 2001, what is the difference between the Value added (current US$) in Faeroe Islands and Value added (current US$) in Turkmenistan?
Your answer should be very brief. -4.68e+08. In the year 2002, what is the difference between the Value added (current US$) of Algeria and Value added (current US$) of Djibouti?
Give a very brief answer. 2.00e+1. In the year 2002, what is the difference between the Value added (current US$) of Algeria and Value added (current US$) of Faeroe Islands?
Provide a short and direct response. 1.98e+1. In the year 2002, what is the difference between the Value added (current US$) in Algeria and Value added (current US$) in Turkmenistan?
Keep it short and to the point. 1.90e+1. In the year 2002, what is the difference between the Value added (current US$) of Djibouti and Value added (current US$) of Faeroe Islands?
Your response must be concise. -2.43e+08. In the year 2002, what is the difference between the Value added (current US$) of Djibouti and Value added (current US$) of Turkmenistan?
Offer a terse response. -1.09e+09. In the year 2002, what is the difference between the Value added (current US$) of Faeroe Islands and Value added (current US$) of Turkmenistan?
Provide a succinct answer. -8.52e+08. In the year 2003, what is the difference between the Value added (current US$) of Algeria and Value added (current US$) of Djibouti?
Your answer should be very brief. 2.29e+1. In the year 2003, what is the difference between the Value added (current US$) in Algeria and Value added (current US$) in Faeroe Islands?
Provide a succinct answer. 2.26e+1. In the year 2003, what is the difference between the Value added (current US$) in Algeria and Value added (current US$) in Turkmenistan?
Offer a very short reply. 2.12e+1. In the year 2003, what is the difference between the Value added (current US$) of Djibouti and Value added (current US$) of Faeroe Islands?
Your response must be concise. -3.91e+08. In the year 2003, what is the difference between the Value added (current US$) in Djibouti and Value added (current US$) in Turkmenistan?
Provide a short and direct response. -1.73e+09. In the year 2003, what is the difference between the Value added (current US$) of Faeroe Islands and Value added (current US$) of Turkmenistan?
Provide a short and direct response. -1.34e+09. In the year 2004, what is the difference between the Value added (current US$) of Algeria and Value added (current US$) of Djibouti?
Offer a very short reply. 2.82e+1. In the year 2004, what is the difference between the Value added (current US$) in Algeria and Value added (current US$) in Faeroe Islands?
Offer a very short reply. 2.77e+1. In the year 2004, what is the difference between the Value added (current US$) of Algeria and Value added (current US$) of Turkmenistan?
Offer a terse response. 2.60e+1. In the year 2004, what is the difference between the Value added (current US$) of Djibouti and Value added (current US$) of Faeroe Islands?
Give a very brief answer. -4.81e+08. In the year 2004, what is the difference between the Value added (current US$) in Djibouti and Value added (current US$) in Turkmenistan?
Make the answer very short. -2.15e+09. In the year 2004, what is the difference between the Value added (current US$) of Faeroe Islands and Value added (current US$) of Turkmenistan?
Keep it short and to the point. -1.67e+09. In the year 2005, what is the difference between the Value added (current US$) of Algeria and Value added (current US$) of Djibouti?
Keep it short and to the point. 3.14e+1. In the year 2005, what is the difference between the Value added (current US$) in Algeria and Value added (current US$) in Faeroe Islands?
Offer a very short reply. 3.10e+1. In the year 2005, what is the difference between the Value added (current US$) of Algeria and Value added (current US$) of Turkmenistan?
Offer a very short reply. 2.85e+1. In the year 2005, what is the difference between the Value added (current US$) of Djibouti and Value added (current US$) of Faeroe Islands?
Make the answer very short. -4.73e+08. In the year 2005, what is the difference between the Value added (current US$) in Djibouti and Value added (current US$) in Turkmenistan?
Your answer should be very brief. -2.98e+09. In the year 2005, what is the difference between the Value added (current US$) of Faeroe Islands and Value added (current US$) of Turkmenistan?
Your answer should be compact. -2.50e+09. In the year 2006, what is the difference between the Value added (current US$) of Algeria and Value added (current US$) of Djibouti?
Offer a terse response. 3.57e+1. In the year 2006, what is the difference between the Value added (current US$) of Algeria and Value added (current US$) of Faeroe Islands?
Keep it short and to the point. 3.52e+1. In the year 2006, what is the difference between the Value added (current US$) of Algeria and Value added (current US$) of Turkmenistan?
Your answer should be compact. 3.15e+1. In the year 2006, what is the difference between the Value added (current US$) of Djibouti and Value added (current US$) of Faeroe Islands?
Provide a succinct answer. -5.09e+08. In the year 2006, what is the difference between the Value added (current US$) in Djibouti and Value added (current US$) in Turkmenistan?
Offer a terse response. -4.14e+09. In the year 2006, what is the difference between the Value added (current US$) in Faeroe Islands and Value added (current US$) in Turkmenistan?
Your response must be concise. -3.63e+09. In the year 2007, what is the difference between the Value added (current US$) of Algeria and Value added (current US$) of Djibouti?
Offer a terse response. 4.43e+1. In the year 2007, what is the difference between the Value added (current US$) of Algeria and Value added (current US$) of Faeroe Islands?
Give a very brief answer. 4.36e+1. In the year 2007, what is the difference between the Value added (current US$) of Algeria and Value added (current US$) of Turkmenistan?
Make the answer very short. 3.95e+1. In the year 2007, what is the difference between the Value added (current US$) of Djibouti and Value added (current US$) of Faeroe Islands?
Give a very brief answer. -6.57e+08. In the year 2007, what is the difference between the Value added (current US$) of Djibouti and Value added (current US$) of Turkmenistan?
Provide a succinct answer. -4.76e+09. In the year 2007, what is the difference between the Value added (current US$) in Faeroe Islands and Value added (current US$) in Turkmenistan?
Ensure brevity in your answer.  -4.11e+09. What is the ratio of the Value added (current US$) of Algeria in 2000 to that in 2001?
Make the answer very short. 0.86. What is the ratio of the Value added (current US$) of Djibouti in 2000 to that in 2001?
Provide a short and direct response. 0.96. What is the ratio of the Value added (current US$) of Faeroe Islands in 2000 to that in 2001?
Keep it short and to the point. 0.92. What is the ratio of the Value added (current US$) of Turkmenistan in 2000 to that in 2001?
Keep it short and to the point. 0.8. What is the ratio of the Value added (current US$) in Algeria in 2000 to that in 2002?
Offer a very short reply. 0.82. What is the ratio of the Value added (current US$) in Djibouti in 2000 to that in 2002?
Make the answer very short. 0.94. What is the ratio of the Value added (current US$) of Faeroe Islands in 2000 to that in 2002?
Give a very brief answer. 0.82. What is the ratio of the Value added (current US$) of Turkmenistan in 2000 to that in 2002?
Offer a terse response. 0.56. What is the ratio of the Value added (current US$) in Algeria in 2000 to that in 2003?
Offer a terse response. 0.72. What is the ratio of the Value added (current US$) in Djibouti in 2000 to that in 2003?
Give a very brief answer. 0.9. What is the ratio of the Value added (current US$) of Faeroe Islands in 2000 to that in 2003?
Offer a very short reply. 0.65. What is the ratio of the Value added (current US$) in Turkmenistan in 2000 to that in 2003?
Your response must be concise. 0.39. What is the ratio of the Value added (current US$) of Algeria in 2000 to that in 2004?
Provide a short and direct response. 0.59. What is the ratio of the Value added (current US$) of Djibouti in 2000 to that in 2004?
Give a very brief answer. 0.84. What is the ratio of the Value added (current US$) in Faeroe Islands in 2000 to that in 2004?
Ensure brevity in your answer.  0.57. What is the ratio of the Value added (current US$) of Turkmenistan in 2000 to that in 2004?
Your response must be concise. 0.32. What is the ratio of the Value added (current US$) in Algeria in 2000 to that in 2005?
Your answer should be very brief. 0.53. What is the ratio of the Value added (current US$) of Djibouti in 2000 to that in 2005?
Ensure brevity in your answer.  0.78. What is the ratio of the Value added (current US$) in Faeroe Islands in 2000 to that in 2005?
Provide a succinct answer. 0.55. What is the ratio of the Value added (current US$) in Turkmenistan in 2000 to that in 2005?
Provide a short and direct response. 0.24. What is the ratio of the Value added (current US$) in Algeria in 2000 to that in 2006?
Your answer should be very brief. 0.46. What is the ratio of the Value added (current US$) of Djibouti in 2000 to that in 2006?
Ensure brevity in your answer.  0.71. What is the ratio of the Value added (current US$) in Faeroe Islands in 2000 to that in 2006?
Your response must be concise. 0.51. What is the ratio of the Value added (current US$) in Turkmenistan in 2000 to that in 2006?
Ensure brevity in your answer.  0.18. What is the ratio of the Value added (current US$) of Algeria in 2000 to that in 2007?
Provide a succinct answer. 0.38. What is the ratio of the Value added (current US$) in Djibouti in 2000 to that in 2007?
Provide a succinct answer. 0.66. What is the ratio of the Value added (current US$) of Faeroe Islands in 2000 to that in 2007?
Your answer should be compact. 0.43. What is the ratio of the Value added (current US$) of Turkmenistan in 2000 to that in 2007?
Your response must be concise. 0.16. What is the ratio of the Value added (current US$) in Algeria in 2001 to that in 2002?
Provide a short and direct response. 0.96. What is the ratio of the Value added (current US$) of Djibouti in 2001 to that in 2002?
Provide a short and direct response. 0.98. What is the ratio of the Value added (current US$) of Faeroe Islands in 2001 to that in 2002?
Give a very brief answer. 0.89. What is the ratio of the Value added (current US$) in Turkmenistan in 2001 to that in 2002?
Offer a very short reply. 0.7. What is the ratio of the Value added (current US$) in Algeria in 2001 to that in 2003?
Offer a very short reply. 0.84. What is the ratio of the Value added (current US$) of Djibouti in 2001 to that in 2003?
Provide a succinct answer. 0.94. What is the ratio of the Value added (current US$) of Faeroe Islands in 2001 to that in 2003?
Offer a terse response. 0.71. What is the ratio of the Value added (current US$) in Turkmenistan in 2001 to that in 2003?
Your answer should be compact. 0.49. What is the ratio of the Value added (current US$) of Algeria in 2001 to that in 2004?
Provide a short and direct response. 0.68. What is the ratio of the Value added (current US$) in Djibouti in 2001 to that in 2004?
Provide a succinct answer. 0.88. What is the ratio of the Value added (current US$) of Faeroe Islands in 2001 to that in 2004?
Ensure brevity in your answer.  0.62. What is the ratio of the Value added (current US$) of Turkmenistan in 2001 to that in 2004?
Offer a terse response. 0.4. What is the ratio of the Value added (current US$) of Algeria in 2001 to that in 2005?
Offer a terse response. 0.61. What is the ratio of the Value added (current US$) in Djibouti in 2001 to that in 2005?
Make the answer very short. 0.81. What is the ratio of the Value added (current US$) in Faeroe Islands in 2001 to that in 2005?
Make the answer very short. 0.6. What is the ratio of the Value added (current US$) in Turkmenistan in 2001 to that in 2005?
Give a very brief answer. 0.3. What is the ratio of the Value added (current US$) in Algeria in 2001 to that in 2006?
Give a very brief answer. 0.54. What is the ratio of the Value added (current US$) in Djibouti in 2001 to that in 2006?
Give a very brief answer. 0.74. What is the ratio of the Value added (current US$) of Faeroe Islands in 2001 to that in 2006?
Ensure brevity in your answer.  0.55. What is the ratio of the Value added (current US$) of Turkmenistan in 2001 to that in 2006?
Offer a very short reply. 0.22. What is the ratio of the Value added (current US$) of Algeria in 2001 to that in 2007?
Make the answer very short. 0.44. What is the ratio of the Value added (current US$) of Djibouti in 2001 to that in 2007?
Offer a terse response. 0.69. What is the ratio of the Value added (current US$) of Faeroe Islands in 2001 to that in 2007?
Ensure brevity in your answer.  0.47. What is the ratio of the Value added (current US$) of Turkmenistan in 2001 to that in 2007?
Give a very brief answer. 0.2. What is the ratio of the Value added (current US$) of Algeria in 2002 to that in 2003?
Provide a short and direct response. 0.88. What is the ratio of the Value added (current US$) in Djibouti in 2002 to that in 2003?
Keep it short and to the point. 0.96. What is the ratio of the Value added (current US$) in Faeroe Islands in 2002 to that in 2003?
Offer a very short reply. 0.8. What is the ratio of the Value added (current US$) of Turkmenistan in 2002 to that in 2003?
Provide a short and direct response. 0.7. What is the ratio of the Value added (current US$) of Algeria in 2002 to that in 2004?
Provide a short and direct response. 0.71. What is the ratio of the Value added (current US$) of Djibouti in 2002 to that in 2004?
Give a very brief answer. 0.9. What is the ratio of the Value added (current US$) in Faeroe Islands in 2002 to that in 2004?
Give a very brief answer. 0.7. What is the ratio of the Value added (current US$) in Turkmenistan in 2002 to that in 2004?
Provide a short and direct response. 0.58. What is the ratio of the Value added (current US$) of Algeria in 2002 to that in 2005?
Give a very brief answer. 0.64. What is the ratio of the Value added (current US$) of Djibouti in 2002 to that in 2005?
Offer a very short reply. 0.83. What is the ratio of the Value added (current US$) of Faeroe Islands in 2002 to that in 2005?
Provide a succinct answer. 0.67. What is the ratio of the Value added (current US$) of Turkmenistan in 2002 to that in 2005?
Keep it short and to the point. 0.43. What is the ratio of the Value added (current US$) in Algeria in 2002 to that in 2006?
Your answer should be compact. 0.56. What is the ratio of the Value added (current US$) in Djibouti in 2002 to that in 2006?
Keep it short and to the point. 0.76. What is the ratio of the Value added (current US$) of Faeroe Islands in 2002 to that in 2006?
Offer a very short reply. 0.62. What is the ratio of the Value added (current US$) in Turkmenistan in 2002 to that in 2006?
Offer a terse response. 0.32. What is the ratio of the Value added (current US$) of Algeria in 2002 to that in 2007?
Your answer should be very brief. 0.46. What is the ratio of the Value added (current US$) in Djibouti in 2002 to that in 2007?
Give a very brief answer. 0.7. What is the ratio of the Value added (current US$) of Faeroe Islands in 2002 to that in 2007?
Your answer should be compact. 0.53. What is the ratio of the Value added (current US$) of Turkmenistan in 2002 to that in 2007?
Ensure brevity in your answer.  0.28. What is the ratio of the Value added (current US$) of Algeria in 2003 to that in 2004?
Provide a succinct answer. 0.82. What is the ratio of the Value added (current US$) in Djibouti in 2003 to that in 2004?
Your answer should be very brief. 0.93. What is the ratio of the Value added (current US$) in Faeroe Islands in 2003 to that in 2004?
Provide a succinct answer. 0.87. What is the ratio of the Value added (current US$) of Turkmenistan in 2003 to that in 2004?
Your answer should be compact. 0.83. What is the ratio of the Value added (current US$) in Algeria in 2003 to that in 2005?
Make the answer very short. 0.73. What is the ratio of the Value added (current US$) in Djibouti in 2003 to that in 2005?
Provide a short and direct response. 0.86. What is the ratio of the Value added (current US$) of Faeroe Islands in 2003 to that in 2005?
Your response must be concise. 0.84. What is the ratio of the Value added (current US$) of Turkmenistan in 2003 to that in 2005?
Keep it short and to the point. 0.62. What is the ratio of the Value added (current US$) in Algeria in 2003 to that in 2006?
Give a very brief answer. 0.65. What is the ratio of the Value added (current US$) of Djibouti in 2003 to that in 2006?
Provide a succinct answer. 0.79. What is the ratio of the Value added (current US$) of Faeroe Islands in 2003 to that in 2006?
Provide a succinct answer. 0.78. What is the ratio of the Value added (current US$) in Turkmenistan in 2003 to that in 2006?
Your answer should be very brief. 0.46. What is the ratio of the Value added (current US$) in Algeria in 2003 to that in 2007?
Your answer should be very brief. 0.52. What is the ratio of the Value added (current US$) in Djibouti in 2003 to that in 2007?
Offer a terse response. 0.73. What is the ratio of the Value added (current US$) in Faeroe Islands in 2003 to that in 2007?
Provide a short and direct response. 0.66. What is the ratio of the Value added (current US$) of Turkmenistan in 2003 to that in 2007?
Offer a terse response. 0.4. What is the ratio of the Value added (current US$) of Algeria in 2004 to that in 2005?
Your answer should be compact. 0.9. What is the ratio of the Value added (current US$) in Djibouti in 2004 to that in 2005?
Keep it short and to the point. 0.92. What is the ratio of the Value added (current US$) in Faeroe Islands in 2004 to that in 2005?
Provide a succinct answer. 0.97. What is the ratio of the Value added (current US$) of Turkmenistan in 2004 to that in 2005?
Provide a short and direct response. 0.75. What is the ratio of the Value added (current US$) of Algeria in 2004 to that in 2006?
Offer a terse response. 0.79. What is the ratio of the Value added (current US$) of Djibouti in 2004 to that in 2006?
Your answer should be compact. 0.84. What is the ratio of the Value added (current US$) in Faeroe Islands in 2004 to that in 2006?
Provide a succinct answer. 0.89. What is the ratio of the Value added (current US$) in Turkmenistan in 2004 to that in 2006?
Make the answer very short. 0.56. What is the ratio of the Value added (current US$) in Algeria in 2004 to that in 2007?
Provide a succinct answer. 0.64. What is the ratio of the Value added (current US$) in Djibouti in 2004 to that in 2007?
Keep it short and to the point. 0.78. What is the ratio of the Value added (current US$) of Faeroe Islands in 2004 to that in 2007?
Ensure brevity in your answer.  0.75. What is the ratio of the Value added (current US$) of Turkmenistan in 2004 to that in 2007?
Make the answer very short. 0.49. What is the ratio of the Value added (current US$) of Algeria in 2005 to that in 2006?
Offer a terse response. 0.88. What is the ratio of the Value added (current US$) of Djibouti in 2005 to that in 2006?
Make the answer very short. 0.92. What is the ratio of the Value added (current US$) in Turkmenistan in 2005 to that in 2006?
Your answer should be very brief. 0.74. What is the ratio of the Value added (current US$) in Algeria in 2005 to that in 2007?
Your response must be concise. 0.71. What is the ratio of the Value added (current US$) of Djibouti in 2005 to that in 2007?
Keep it short and to the point. 0.85. What is the ratio of the Value added (current US$) in Faeroe Islands in 2005 to that in 2007?
Provide a succinct answer. 0.78. What is the ratio of the Value added (current US$) in Turkmenistan in 2005 to that in 2007?
Make the answer very short. 0.65. What is the ratio of the Value added (current US$) in Algeria in 2006 to that in 2007?
Your answer should be compact. 0.81. What is the ratio of the Value added (current US$) in Djibouti in 2006 to that in 2007?
Your answer should be very brief. 0.93. What is the ratio of the Value added (current US$) in Faeroe Islands in 2006 to that in 2007?
Your answer should be very brief. 0.85. What is the ratio of the Value added (current US$) of Turkmenistan in 2006 to that in 2007?
Offer a very short reply. 0.88. What is the difference between the highest and the second highest Value added (current US$) of Algeria?
Provide a short and direct response. 8.61e+09. What is the difference between the highest and the second highest Value added (current US$) in Djibouti?
Your answer should be very brief. 4.30e+07. What is the difference between the highest and the second highest Value added (current US$) of Faeroe Islands?
Ensure brevity in your answer.  1.92e+08. What is the difference between the highest and the second highest Value added (current US$) of Turkmenistan?
Give a very brief answer. 6.68e+08. What is the difference between the highest and the lowest Value added (current US$) in Algeria?
Offer a terse response. 2.80e+1. What is the difference between the highest and the lowest Value added (current US$) in Djibouti?
Offer a terse response. 2.02e+08. What is the difference between the highest and the lowest Value added (current US$) in Faeroe Islands?
Offer a terse response. 7.12e+08. What is the difference between the highest and the lowest Value added (current US$) of Turkmenistan?
Keep it short and to the point. 4.52e+09. 